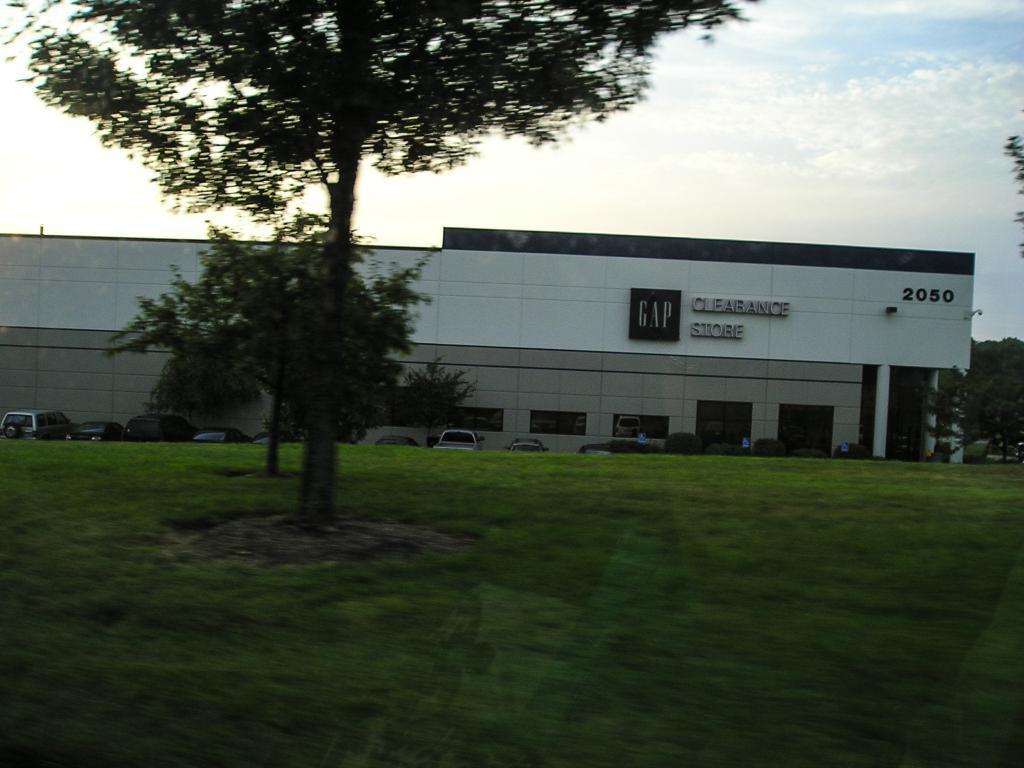Could you give a brief overview of what you see in this image? This image is taken outdoors. At the bottom of the image there is a ground with grass on it. At the top of the image there is the sky with clouds. In the middle of the image there is a building with walls, windows, doors and roof. There is a text on a wall. There are a few trees. Many cars are parked on the ground. 